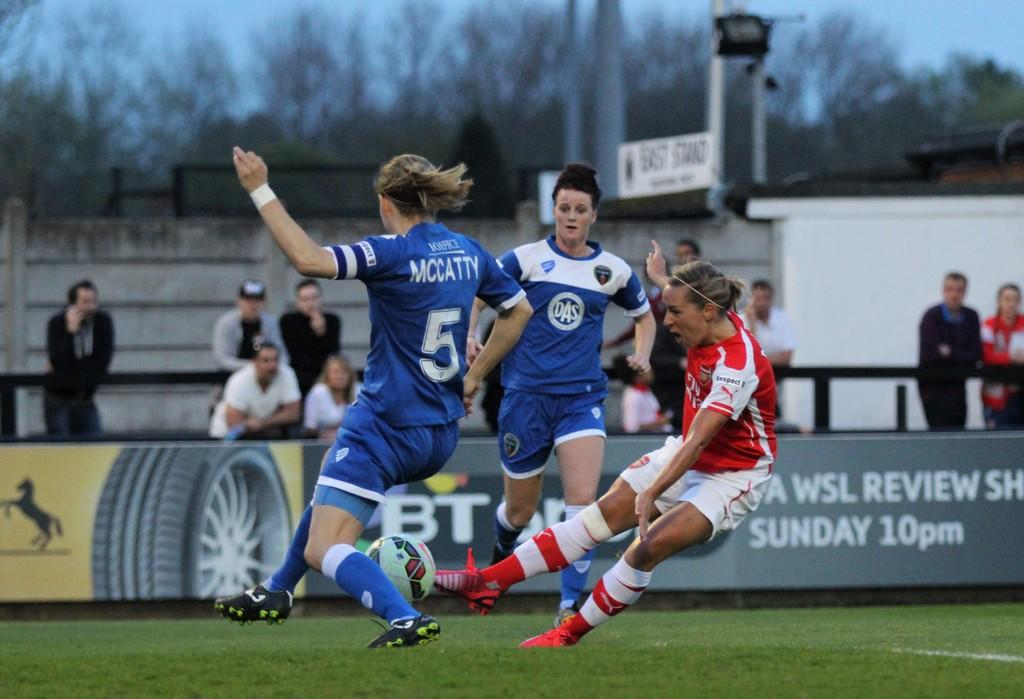<image>
Present a compact description of the photo's key features. Player number 5 in blue defends in this hotly contested soccer match. 